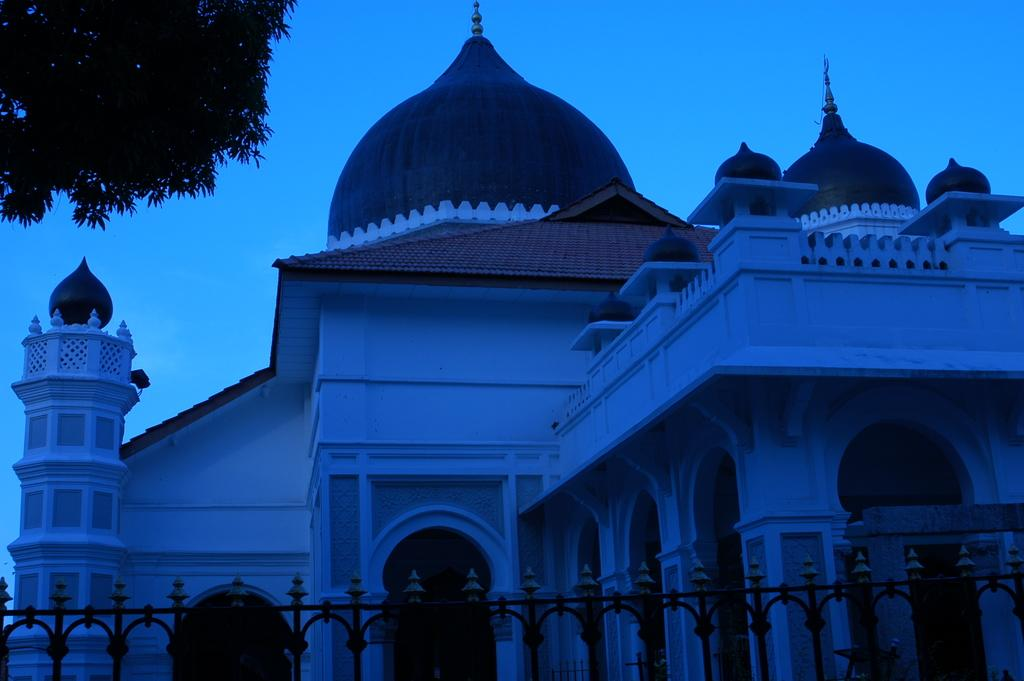What type of structure is present in the image? There is a building in the image. What can be seen surrounding the building? There is a fence in the image. What type of natural element is present in the image? There is a tree in the image. What is visible in the background of the image? The sky is visible in the image. How many eggs are being transported in the order shown in the image? There are no eggs, transportation, or orders present in the image. 